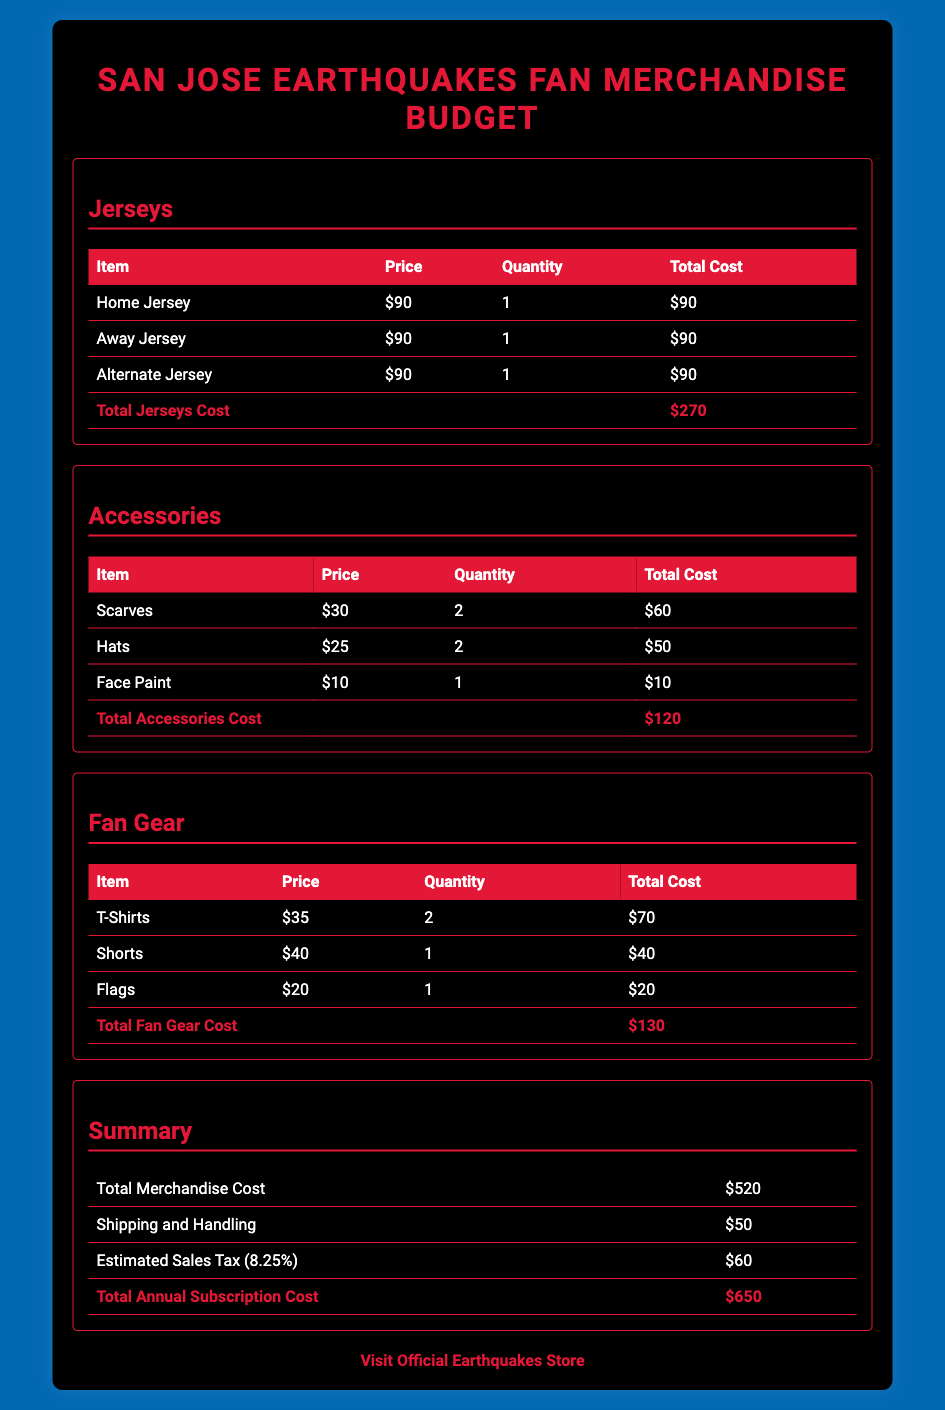What is the total cost for jerseys? The total cost for jerseys is calculated by adding up the costs of the Home, Away, and Alternate jerseys, which equals $90 + $90 + $90.
Answer: $270 How many scarves are included in the budget? The number of scarves included is specified in the Accessories section, which lists 2 scarves.
Answer: 2 What is the price of a home jersey? The price for a Home Jersey is shown in the Jerseys section as $90.
Answer: $90 What is the estimated sales tax? The estimated sales tax is mentioned in the Summary section as $60.
Answer: $60 What is the total merchandise cost before shipping and tax? The total merchandise cost before shipping and tax is noted in the Summary section as $520.
Answer: $520 How many types of fan gear are listed in the document? The fan gear section lists 3 types: T-Shirts, Shorts, and Flags.
Answer: 3 What is the total annual subscription cost? The total annual subscription cost is found in the Summary section, totaling $650 after shipping and tax.
Answer: $650 What is the quantity of hats purchased? The quantity of hats is listed in the Accessories section as 2.
Answer: 2 What is the price of the alternate jersey? The price for an Alternate Jersey is $90, as indicated in the Jerseys section.
Answer: $90 